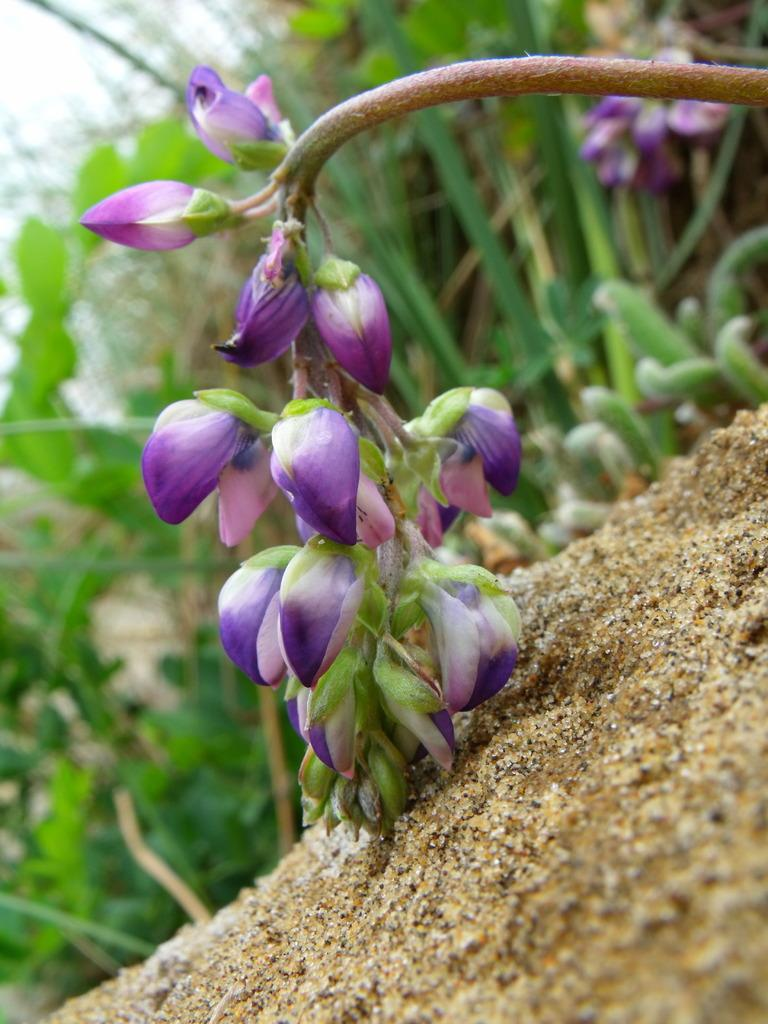What type of flora can be seen in the image? There are flowers in the image. What type of terrain is visible in the image? There is sand visible in the image. What can be seen in the background of the image? There are plants in the background of the image. What type of wax can be seen melting on the flowers in the image? There is no wax present in the image, and therefore no such activity can be observed. What type of chalk can be seen being used to draw on the sand in the image? There is no chalk present in the image, and therefore no such activity can be observed. 